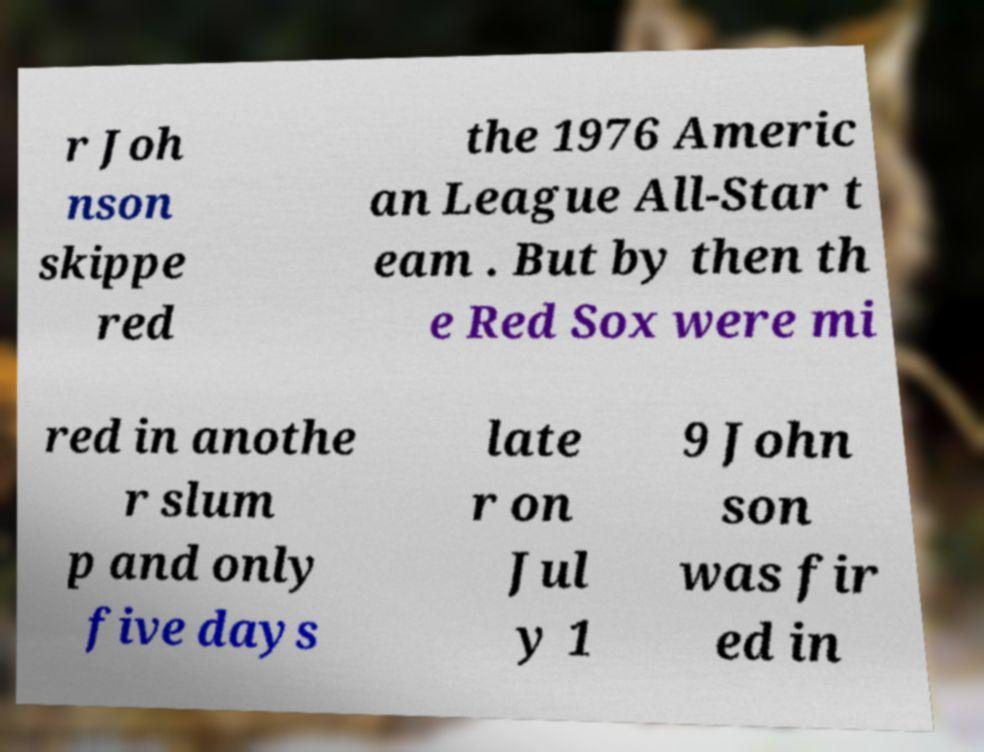Please identify and transcribe the text found in this image. r Joh nson skippe red the 1976 Americ an League All-Star t eam . But by then th e Red Sox were mi red in anothe r slum p and only five days late r on Jul y 1 9 John son was fir ed in 